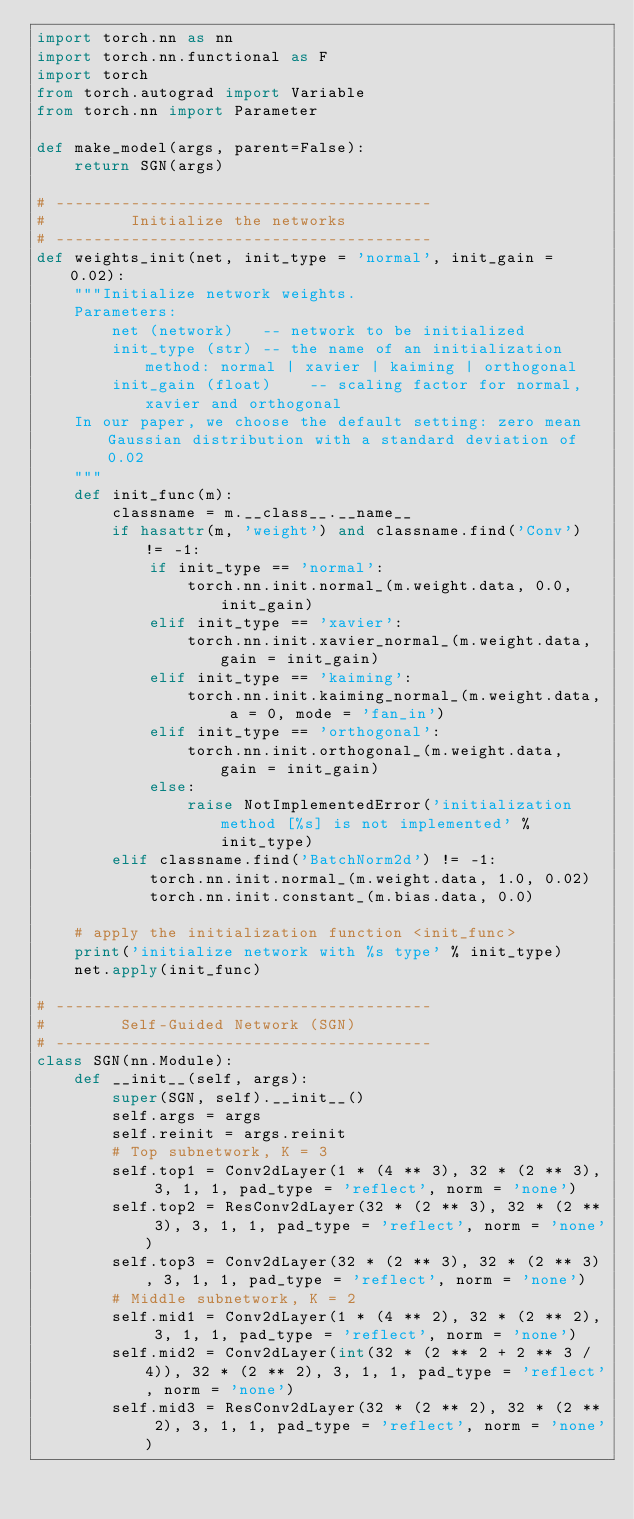<code> <loc_0><loc_0><loc_500><loc_500><_Python_>import torch.nn as nn
import torch.nn.functional as F
import torch
from torch.autograd import Variable
from torch.nn import Parameter

def make_model(args, parent=False):
    return SGN(args)

# ----------------------------------------
#         Initialize the networks
# ----------------------------------------
def weights_init(net, init_type = 'normal', init_gain = 0.02):
    """Initialize network weights.
    Parameters:
        net (network)   -- network to be initialized
        init_type (str) -- the name of an initialization method: normal | xavier | kaiming | orthogonal
        init_gain (float)    -- scaling factor for normal, xavier and orthogonal
    In our paper, we choose the default setting: zero mean Gaussian distribution with a standard deviation of 0.02
    """
    def init_func(m):
        classname = m.__class__.__name__
        if hasattr(m, 'weight') and classname.find('Conv') != -1:
            if init_type == 'normal':
                torch.nn.init.normal_(m.weight.data, 0.0, init_gain)
            elif init_type == 'xavier':
                torch.nn.init.xavier_normal_(m.weight.data, gain = init_gain)
            elif init_type == 'kaiming':
                torch.nn.init.kaiming_normal_(m.weight.data, a = 0, mode = 'fan_in')
            elif init_type == 'orthogonal':
                torch.nn.init.orthogonal_(m.weight.data, gain = init_gain)
            else:
                raise NotImplementedError('initialization method [%s] is not implemented' % init_type)
        elif classname.find('BatchNorm2d') != -1:
            torch.nn.init.normal_(m.weight.data, 1.0, 0.02)
            torch.nn.init.constant_(m.bias.data, 0.0)

    # apply the initialization function <init_func>
    print('initialize network with %s type' % init_type)
    net.apply(init_func)

# ----------------------------------------
#        Self-Guided Network (SGN)
# ----------------------------------------
class SGN(nn.Module):
    def __init__(self, args):
        super(SGN, self).__init__()
        self.args = args
        self.reinit = args.reinit
        # Top subnetwork, K = 3
        self.top1 = Conv2dLayer(1 * (4 ** 3), 32 * (2 ** 3), 3, 1, 1, pad_type = 'reflect', norm = 'none')
        self.top2 = ResConv2dLayer(32 * (2 ** 3), 32 * (2 ** 3), 3, 1, 1, pad_type = 'reflect', norm = 'none')
        self.top3 = Conv2dLayer(32 * (2 ** 3), 32 * (2 ** 3), 3, 1, 1, pad_type = 'reflect', norm = 'none')
        # Middle subnetwork, K = 2
        self.mid1 = Conv2dLayer(1 * (4 ** 2), 32 * (2 ** 2), 3, 1, 1, pad_type = 'reflect', norm = 'none')
        self.mid2 = Conv2dLayer(int(32 * (2 ** 2 + 2 ** 3 / 4)), 32 * (2 ** 2), 3, 1, 1, pad_type = 'reflect', norm = 'none')
        self.mid3 = ResConv2dLayer(32 * (2 ** 2), 32 * (2 ** 2), 3, 1, 1, pad_type = 'reflect', norm = 'none')</code> 